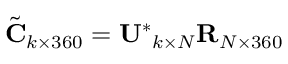Convert formula to latex. <formula><loc_0><loc_0><loc_500><loc_500>\tilde { C } _ { k \times 3 6 0 } = U ^ { * _ { k \times N } R _ { N \times 3 6 0 }</formula> 